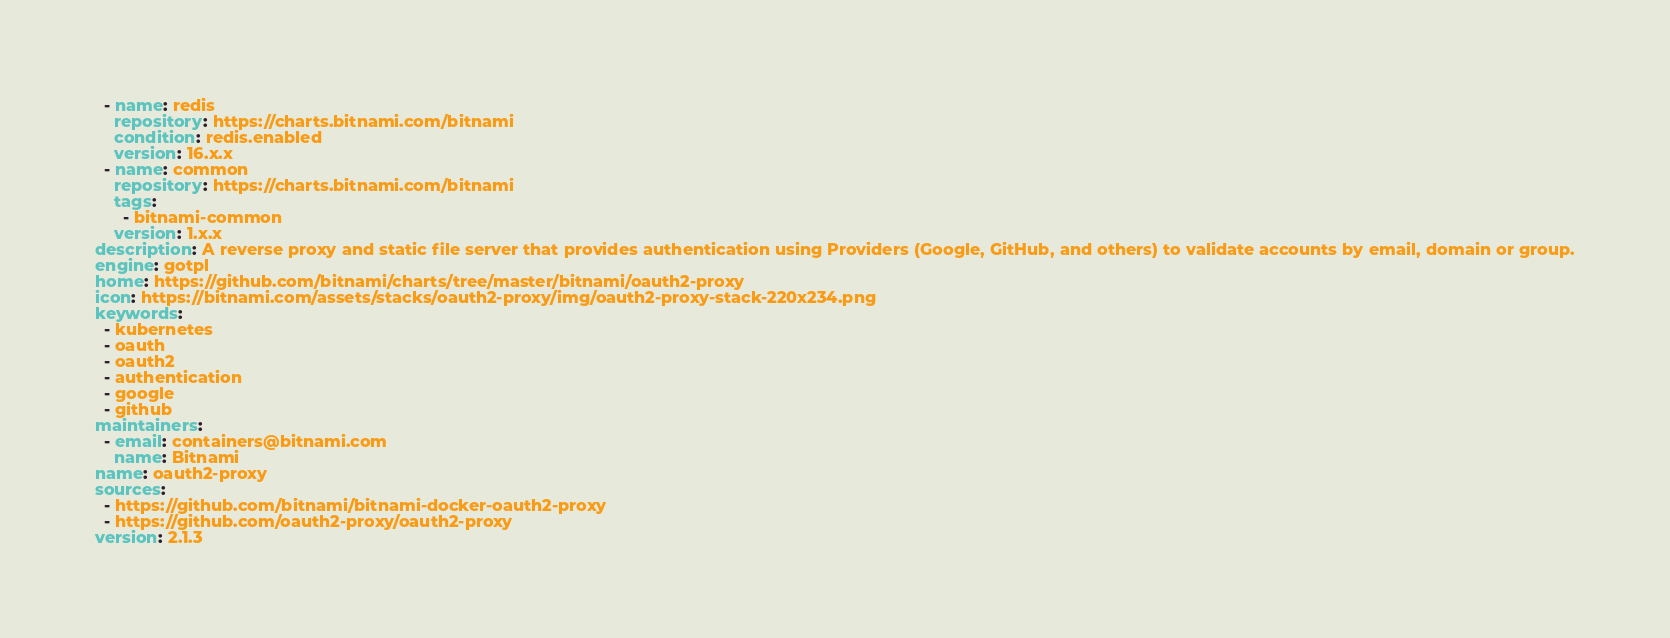<code> <loc_0><loc_0><loc_500><loc_500><_YAML_>  - name: redis
    repository: https://charts.bitnami.com/bitnami
    condition: redis.enabled
    version: 16.x.x
  - name: common
    repository: https://charts.bitnami.com/bitnami
    tags:
      - bitnami-common
    version: 1.x.x
description: A reverse proxy and static file server that provides authentication using Providers (Google, GitHub, and others) to validate accounts by email, domain or group.
engine: gotpl
home: https://github.com/bitnami/charts/tree/master/bitnami/oauth2-proxy
icon: https://bitnami.com/assets/stacks/oauth2-proxy/img/oauth2-proxy-stack-220x234.png
keywords:
  - kubernetes
  - oauth
  - oauth2
  - authentication
  - google
  - github
maintainers:
  - email: containers@bitnami.com
    name: Bitnami
name: oauth2-proxy
sources:
  - https://github.com/bitnami/bitnami-docker-oauth2-proxy
  - https://github.com/oauth2-proxy/oauth2-proxy
version: 2.1.3
</code> 